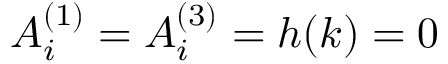Convert formula to latex. <formula><loc_0><loc_0><loc_500><loc_500>A _ { i } ^ { ( 1 ) } = A _ { i } ^ { ( 3 ) } = h ( k ) = 0</formula> 